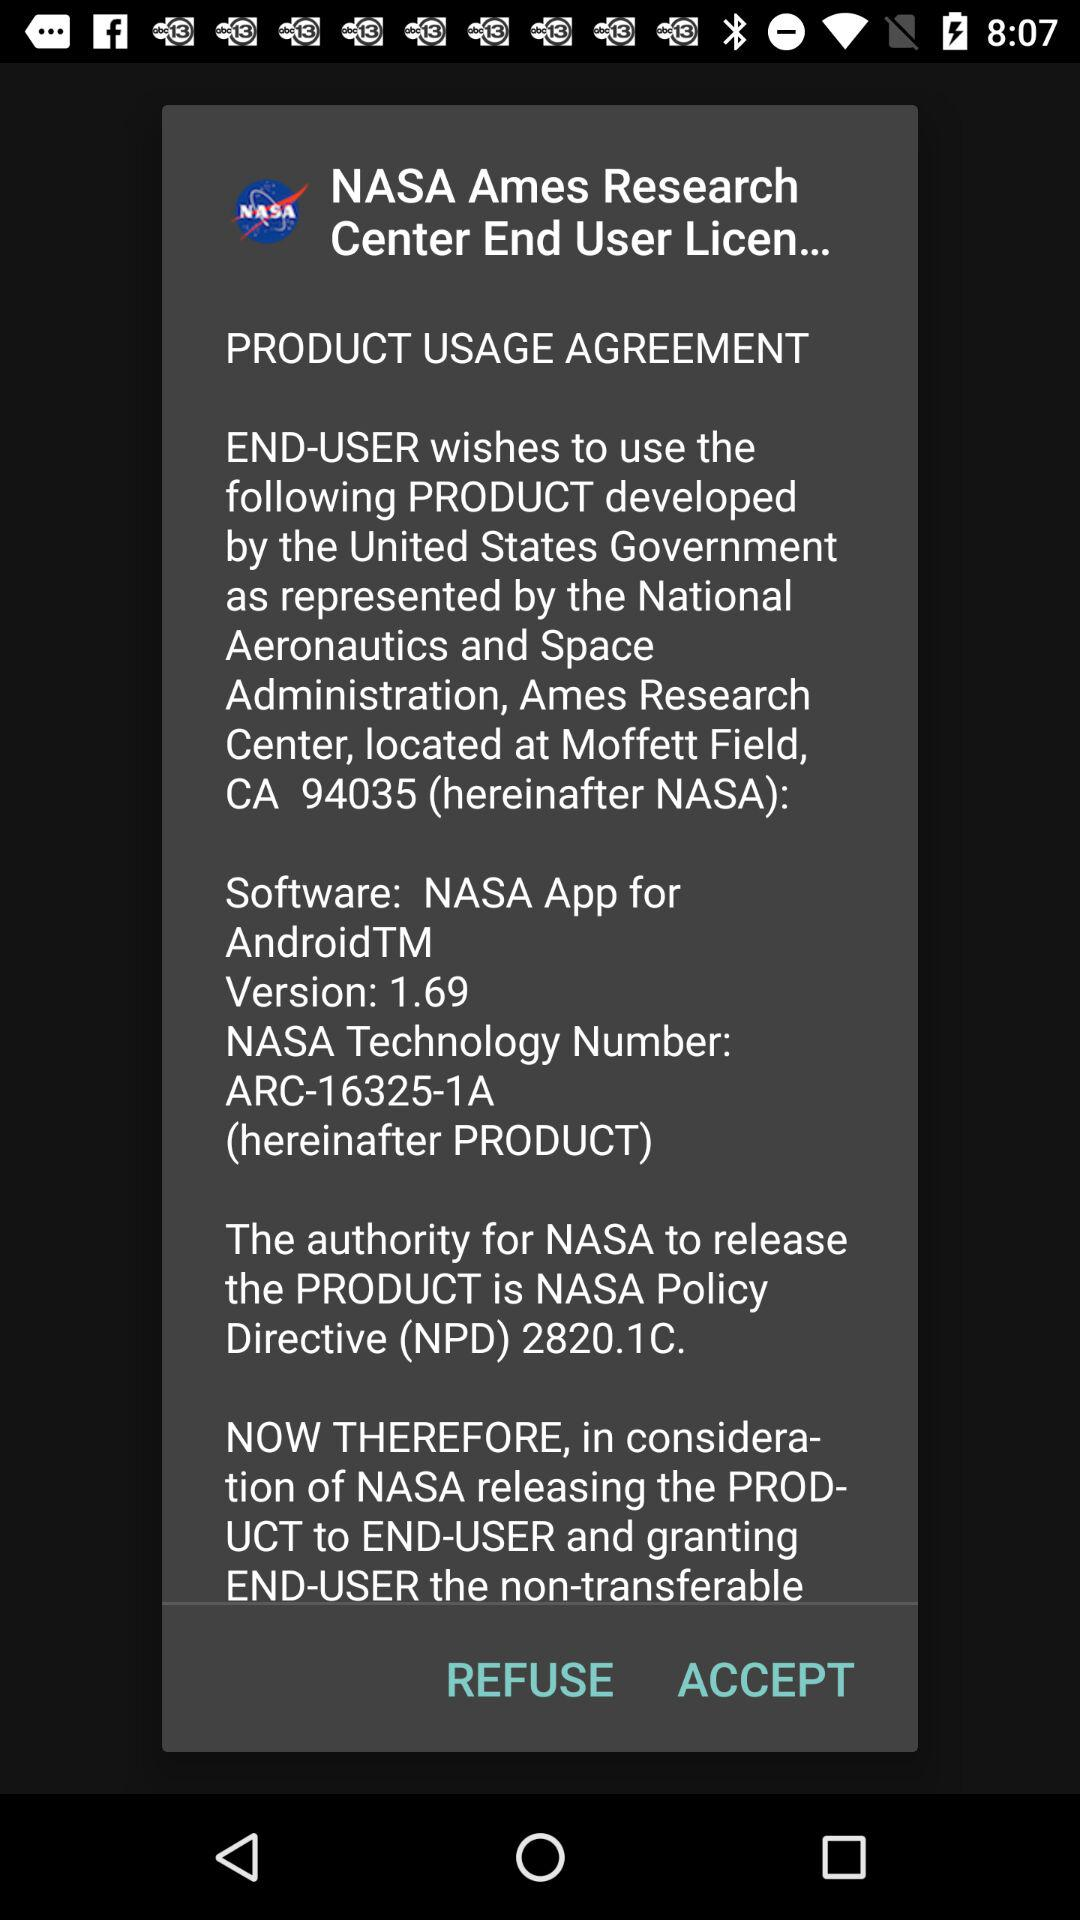What is the application name? The application name is "NASA". 